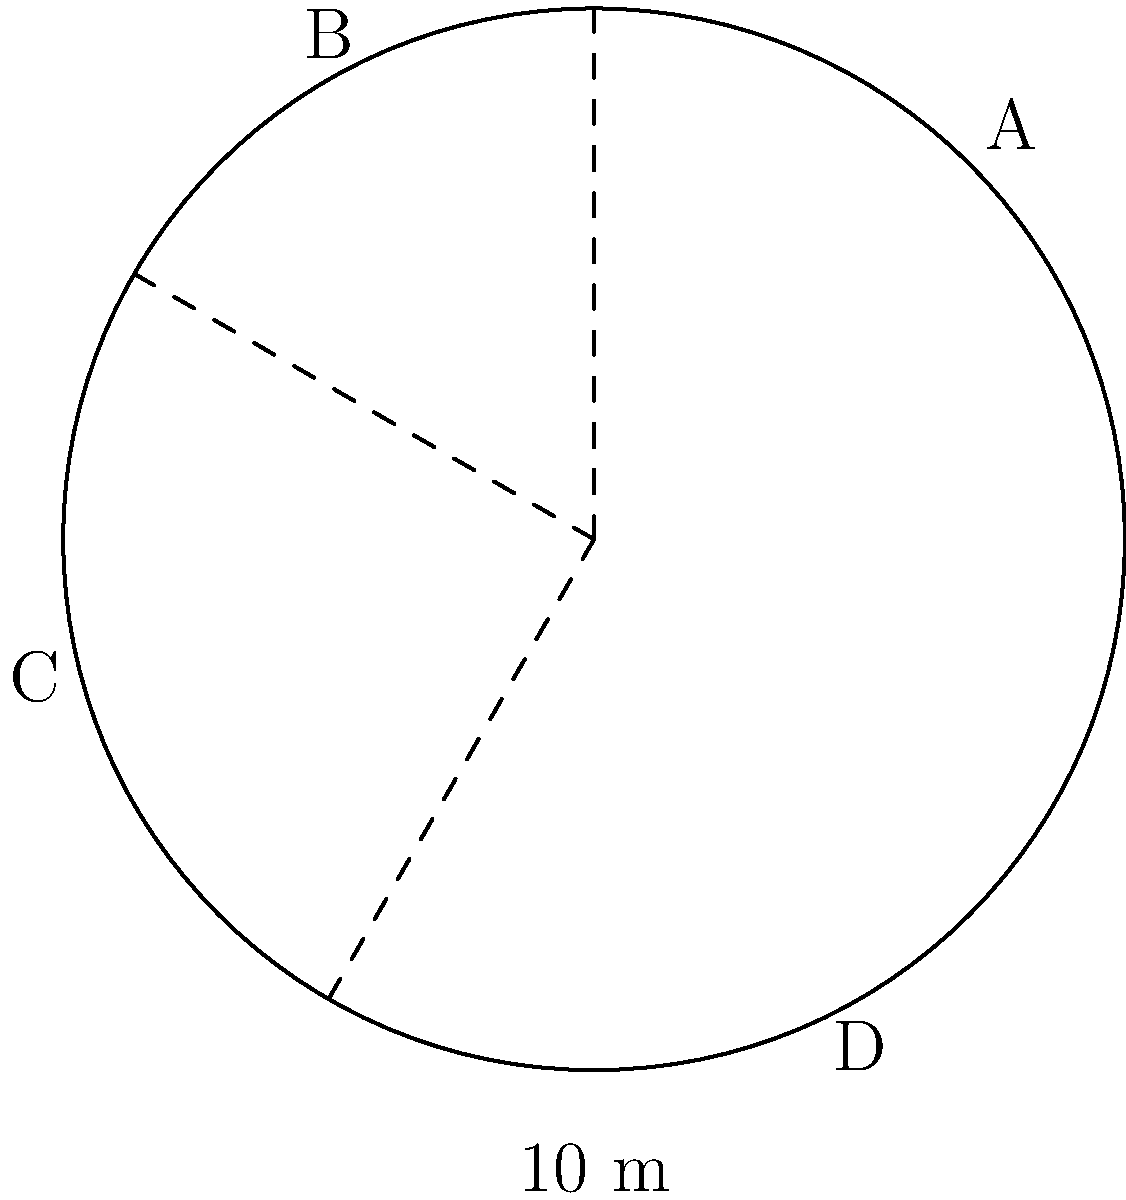A circular field with a radius of 10 meters is used for traditional ceremonies. The field is divided into four sectors: A, B, C, and D, representing different ritual spaces. Sector A spans 90°, sector B spans 60°, sector C spans 90°, and sector D spans the remaining area. What is the area of sector C in square meters? (Use $\pi = 3.14$) To find the area of sector C, we'll follow these steps:

1) First, recall the formula for the area of a circle:
   $A = \pi r^2$

2) The total area of the circle is:
   $A = 3.14 \times 10^2 = 314$ m²

3) The formula for the area of a sector is:
   $A_{sector} = \frac{\theta}{360°} \times \pi r^2$
   where $\theta$ is the central angle in degrees

4) For sector C, $\theta = 90°$

5) Substituting into the sector area formula:
   $A_C = \frac{90}{360} \times 314 = \frac{1}{4} \times 314 = 78.5$ m²

Therefore, the area of sector C is 78.5 square meters.
Answer: 78.5 m² 